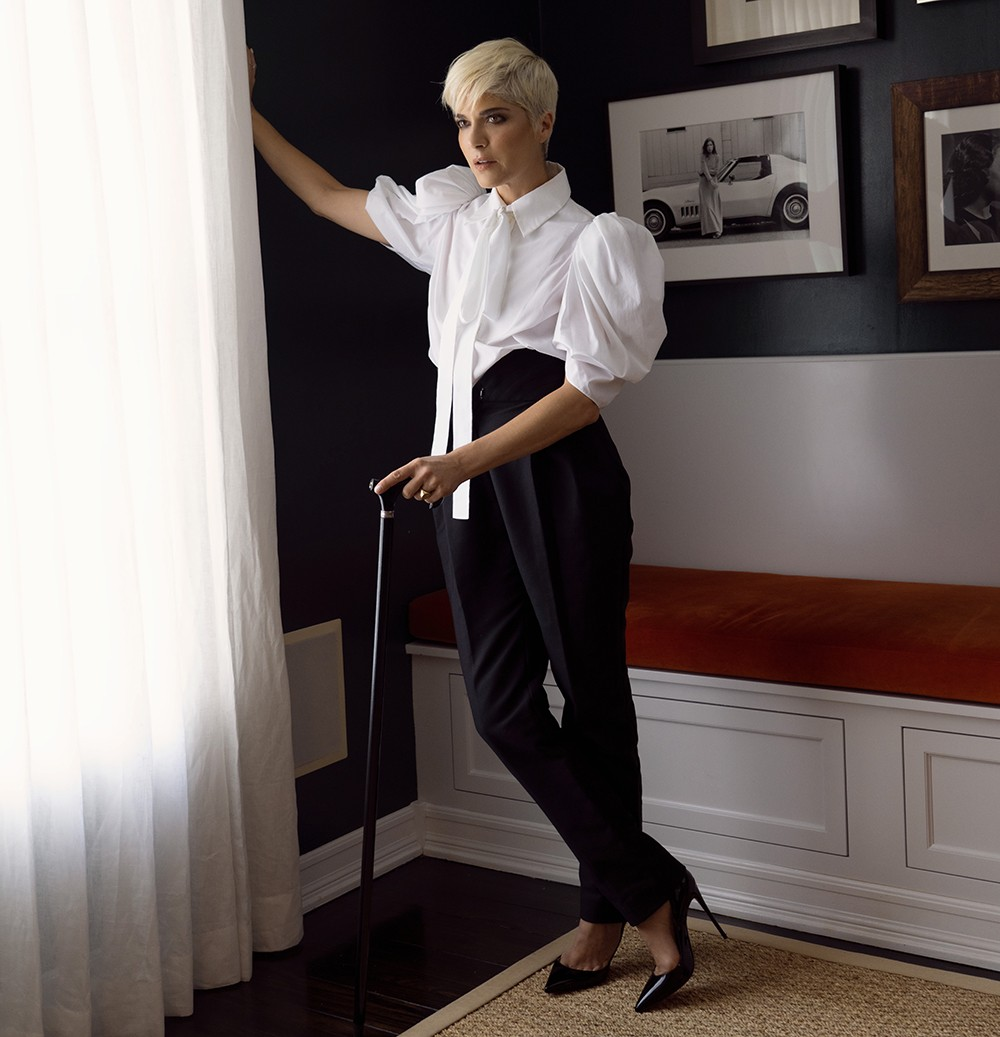What would it be like to spend a day in this room? Spending a day in this room would be a profound experience filled with quiet introspection and tranquility. The stark contrasts of the black and white decor would focus your mind, allowing for deep thought and meditation. The bench with its inviting orange cushion would be the perfect spot for relaxation or a good read. Framed photos and personal mementos on the walls provide an enriching environment for contemplating past journeys and future plans. The presence of the cane and the photo of the car would silently inspire resilience and the spirit of adventure. This room would become a sanctuary, a place where both body and mind could be rejuvenated. 